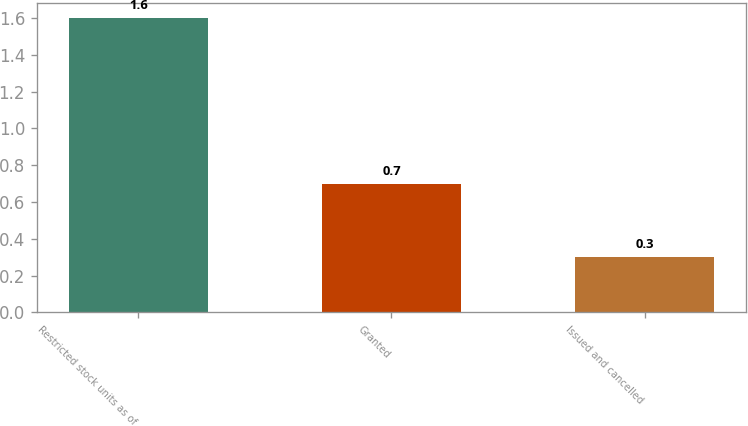<chart> <loc_0><loc_0><loc_500><loc_500><bar_chart><fcel>Restricted stock units as of<fcel>Granted<fcel>Issued and cancelled<nl><fcel>1.6<fcel>0.7<fcel>0.3<nl></chart> 